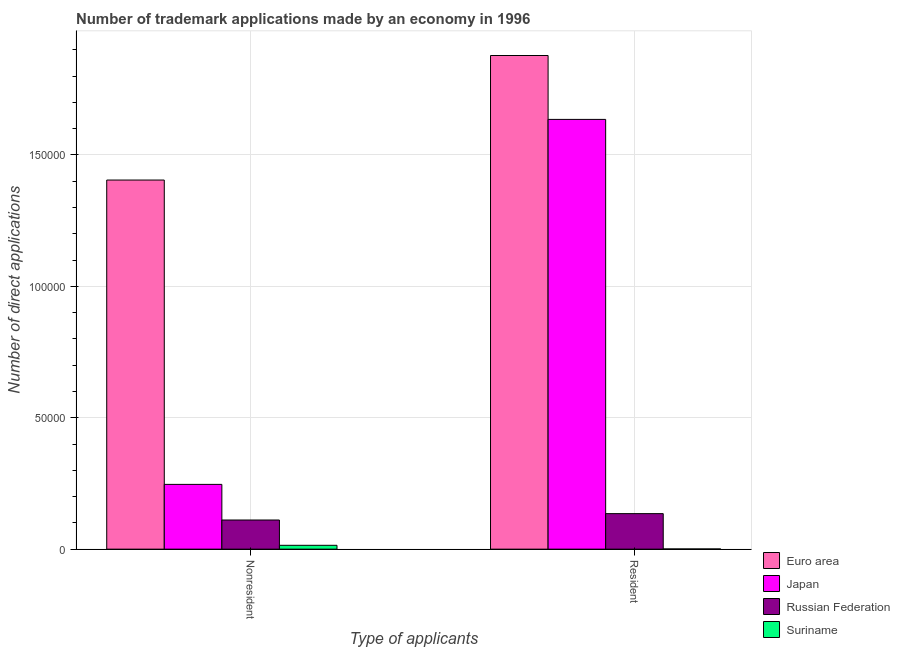How many different coloured bars are there?
Keep it short and to the point. 4. Are the number of bars on each tick of the X-axis equal?
Provide a succinct answer. Yes. How many bars are there on the 1st tick from the right?
Provide a succinct answer. 4. What is the label of the 1st group of bars from the left?
Offer a very short reply. Nonresident. What is the number of trademark applications made by residents in Euro area?
Ensure brevity in your answer.  1.88e+05. Across all countries, what is the maximum number of trademark applications made by non residents?
Keep it short and to the point. 1.40e+05. Across all countries, what is the minimum number of trademark applications made by non residents?
Your answer should be very brief. 1462. In which country was the number of trademark applications made by non residents minimum?
Offer a terse response. Suriname. What is the total number of trademark applications made by residents in the graph?
Offer a very short reply. 3.65e+05. What is the difference between the number of trademark applications made by residents in Japan and that in Euro area?
Keep it short and to the point. -2.43e+04. What is the difference between the number of trademark applications made by non residents in Euro area and the number of trademark applications made by residents in Japan?
Your answer should be compact. -2.31e+04. What is the average number of trademark applications made by non residents per country?
Make the answer very short. 4.44e+04. What is the difference between the number of trademark applications made by non residents and number of trademark applications made by residents in Russian Federation?
Provide a succinct answer. -2423. In how many countries, is the number of trademark applications made by non residents greater than 80000 ?
Your answer should be very brief. 1. What is the ratio of the number of trademark applications made by non residents in Russian Federation to that in Euro area?
Keep it short and to the point. 0.08. What does the 4th bar from the left in Nonresident represents?
Offer a terse response. Suriname. What does the 2nd bar from the right in Resident represents?
Ensure brevity in your answer.  Russian Federation. Are all the bars in the graph horizontal?
Your response must be concise. No. Does the graph contain grids?
Your answer should be compact. Yes. Where does the legend appear in the graph?
Your answer should be very brief. Bottom right. What is the title of the graph?
Offer a terse response. Number of trademark applications made by an economy in 1996. What is the label or title of the X-axis?
Make the answer very short. Type of applicants. What is the label or title of the Y-axis?
Your response must be concise. Number of direct applications. What is the Number of direct applications in Euro area in Nonresident?
Your answer should be very brief. 1.40e+05. What is the Number of direct applications in Japan in Nonresident?
Give a very brief answer. 2.46e+04. What is the Number of direct applications of Russian Federation in Nonresident?
Give a very brief answer. 1.11e+04. What is the Number of direct applications of Suriname in Nonresident?
Offer a terse response. 1462. What is the Number of direct applications in Euro area in Resident?
Your answer should be very brief. 1.88e+05. What is the Number of direct applications of Japan in Resident?
Offer a terse response. 1.64e+05. What is the Number of direct applications of Russian Federation in Resident?
Your response must be concise. 1.35e+04. Across all Type of applicants, what is the maximum Number of direct applications of Euro area?
Keep it short and to the point. 1.88e+05. Across all Type of applicants, what is the maximum Number of direct applications in Japan?
Make the answer very short. 1.64e+05. Across all Type of applicants, what is the maximum Number of direct applications of Russian Federation?
Ensure brevity in your answer.  1.35e+04. Across all Type of applicants, what is the maximum Number of direct applications in Suriname?
Your answer should be very brief. 1462. Across all Type of applicants, what is the minimum Number of direct applications in Euro area?
Offer a very short reply. 1.40e+05. Across all Type of applicants, what is the minimum Number of direct applications of Japan?
Provide a short and direct response. 2.46e+04. Across all Type of applicants, what is the minimum Number of direct applications in Russian Federation?
Ensure brevity in your answer.  1.11e+04. What is the total Number of direct applications in Euro area in the graph?
Your answer should be compact. 3.28e+05. What is the total Number of direct applications in Japan in the graph?
Your response must be concise. 1.88e+05. What is the total Number of direct applications of Russian Federation in the graph?
Your answer should be compact. 2.46e+04. What is the total Number of direct applications of Suriname in the graph?
Provide a succinct answer. 1531. What is the difference between the Number of direct applications of Euro area in Nonresident and that in Resident?
Provide a succinct answer. -4.74e+04. What is the difference between the Number of direct applications in Japan in Nonresident and that in Resident?
Ensure brevity in your answer.  -1.39e+05. What is the difference between the Number of direct applications of Russian Federation in Nonresident and that in Resident?
Offer a very short reply. -2423. What is the difference between the Number of direct applications of Suriname in Nonresident and that in Resident?
Provide a succinct answer. 1393. What is the difference between the Number of direct applications of Euro area in Nonresident and the Number of direct applications of Japan in Resident?
Your response must be concise. -2.31e+04. What is the difference between the Number of direct applications in Euro area in Nonresident and the Number of direct applications in Russian Federation in Resident?
Provide a succinct answer. 1.27e+05. What is the difference between the Number of direct applications of Euro area in Nonresident and the Number of direct applications of Suriname in Resident?
Your answer should be very brief. 1.40e+05. What is the difference between the Number of direct applications in Japan in Nonresident and the Number of direct applications in Russian Federation in Resident?
Offer a very short reply. 1.11e+04. What is the difference between the Number of direct applications in Japan in Nonresident and the Number of direct applications in Suriname in Resident?
Your answer should be compact. 2.46e+04. What is the difference between the Number of direct applications of Russian Federation in Nonresident and the Number of direct applications of Suriname in Resident?
Offer a terse response. 1.10e+04. What is the average Number of direct applications of Euro area per Type of applicants?
Offer a terse response. 1.64e+05. What is the average Number of direct applications of Japan per Type of applicants?
Make the answer very short. 9.41e+04. What is the average Number of direct applications of Russian Federation per Type of applicants?
Give a very brief answer. 1.23e+04. What is the average Number of direct applications of Suriname per Type of applicants?
Your answer should be compact. 765.5. What is the difference between the Number of direct applications of Euro area and Number of direct applications of Japan in Nonresident?
Give a very brief answer. 1.16e+05. What is the difference between the Number of direct applications in Euro area and Number of direct applications in Russian Federation in Nonresident?
Keep it short and to the point. 1.29e+05. What is the difference between the Number of direct applications in Euro area and Number of direct applications in Suriname in Nonresident?
Offer a very short reply. 1.39e+05. What is the difference between the Number of direct applications of Japan and Number of direct applications of Russian Federation in Nonresident?
Provide a short and direct response. 1.36e+04. What is the difference between the Number of direct applications of Japan and Number of direct applications of Suriname in Nonresident?
Ensure brevity in your answer.  2.32e+04. What is the difference between the Number of direct applications of Russian Federation and Number of direct applications of Suriname in Nonresident?
Give a very brief answer. 9628. What is the difference between the Number of direct applications in Euro area and Number of direct applications in Japan in Resident?
Provide a succinct answer. 2.43e+04. What is the difference between the Number of direct applications of Euro area and Number of direct applications of Russian Federation in Resident?
Your answer should be compact. 1.74e+05. What is the difference between the Number of direct applications of Euro area and Number of direct applications of Suriname in Resident?
Give a very brief answer. 1.88e+05. What is the difference between the Number of direct applications in Japan and Number of direct applications in Russian Federation in Resident?
Provide a short and direct response. 1.50e+05. What is the difference between the Number of direct applications in Japan and Number of direct applications in Suriname in Resident?
Your answer should be compact. 1.63e+05. What is the difference between the Number of direct applications of Russian Federation and Number of direct applications of Suriname in Resident?
Your response must be concise. 1.34e+04. What is the ratio of the Number of direct applications of Euro area in Nonresident to that in Resident?
Give a very brief answer. 0.75. What is the ratio of the Number of direct applications of Japan in Nonresident to that in Resident?
Make the answer very short. 0.15. What is the ratio of the Number of direct applications in Russian Federation in Nonresident to that in Resident?
Offer a terse response. 0.82. What is the ratio of the Number of direct applications in Suriname in Nonresident to that in Resident?
Provide a short and direct response. 21.19. What is the difference between the highest and the second highest Number of direct applications of Euro area?
Ensure brevity in your answer.  4.74e+04. What is the difference between the highest and the second highest Number of direct applications of Japan?
Offer a terse response. 1.39e+05. What is the difference between the highest and the second highest Number of direct applications in Russian Federation?
Offer a terse response. 2423. What is the difference between the highest and the second highest Number of direct applications of Suriname?
Offer a very short reply. 1393. What is the difference between the highest and the lowest Number of direct applications of Euro area?
Keep it short and to the point. 4.74e+04. What is the difference between the highest and the lowest Number of direct applications in Japan?
Make the answer very short. 1.39e+05. What is the difference between the highest and the lowest Number of direct applications in Russian Federation?
Provide a short and direct response. 2423. What is the difference between the highest and the lowest Number of direct applications in Suriname?
Make the answer very short. 1393. 